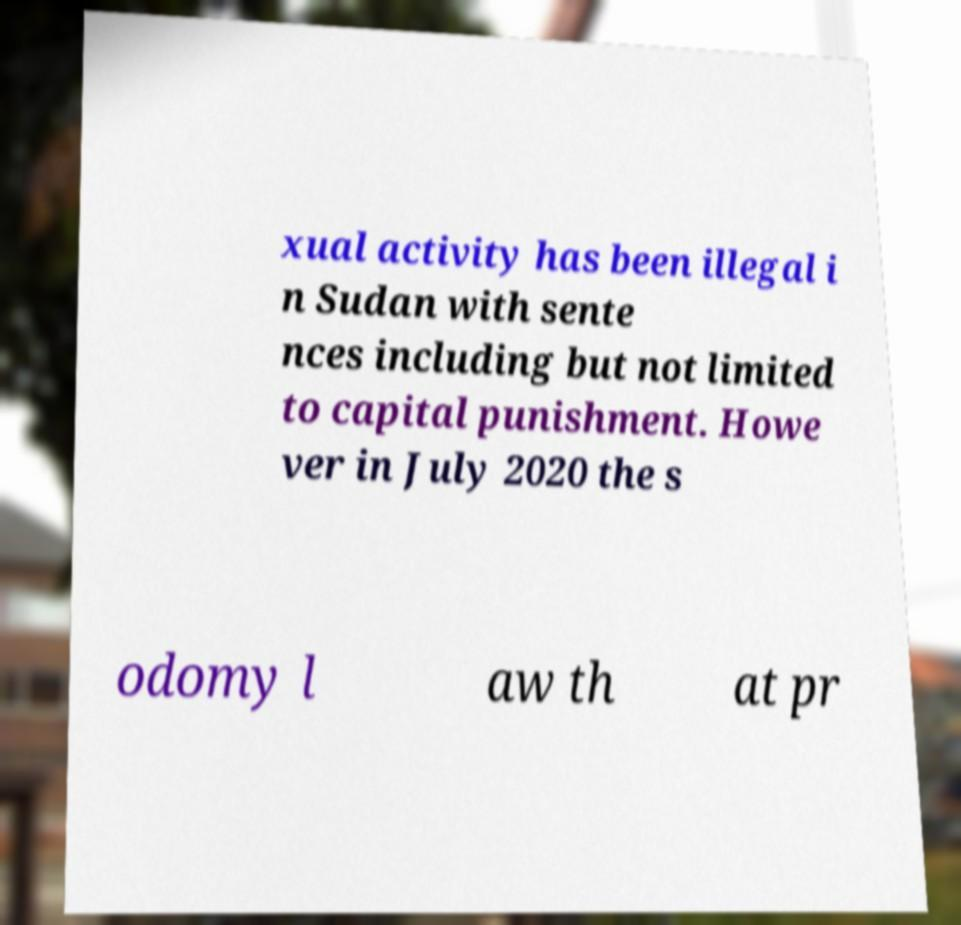What messages or text are displayed in this image? I need them in a readable, typed format. xual activity has been illegal i n Sudan with sente nces including but not limited to capital punishment. Howe ver in July 2020 the s odomy l aw th at pr 